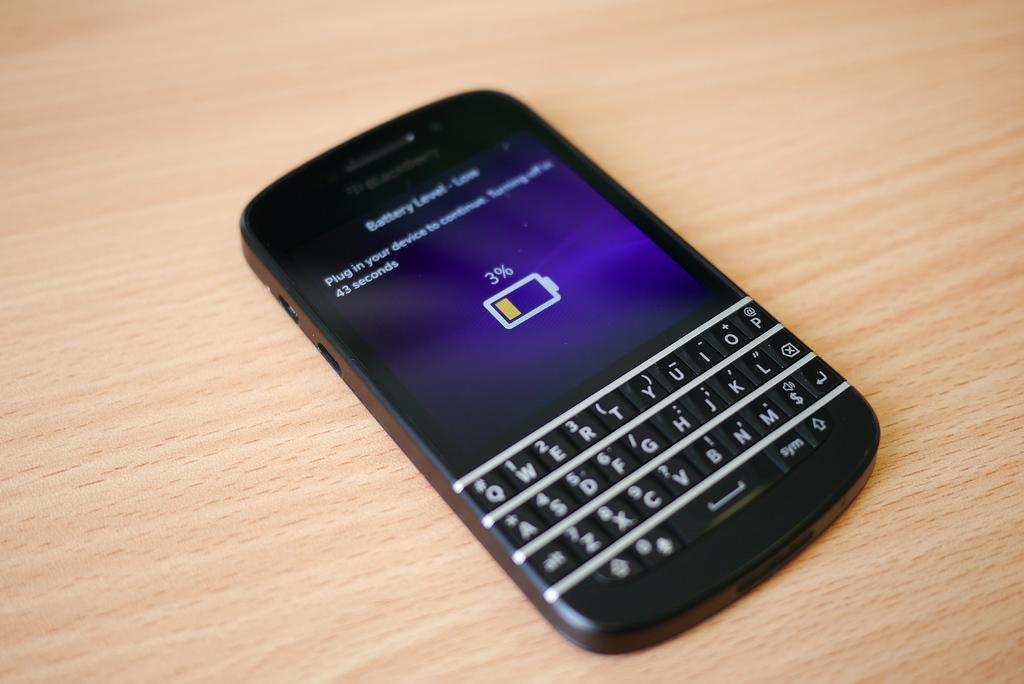What is this screen showing?
Offer a terse response. Battery level. 